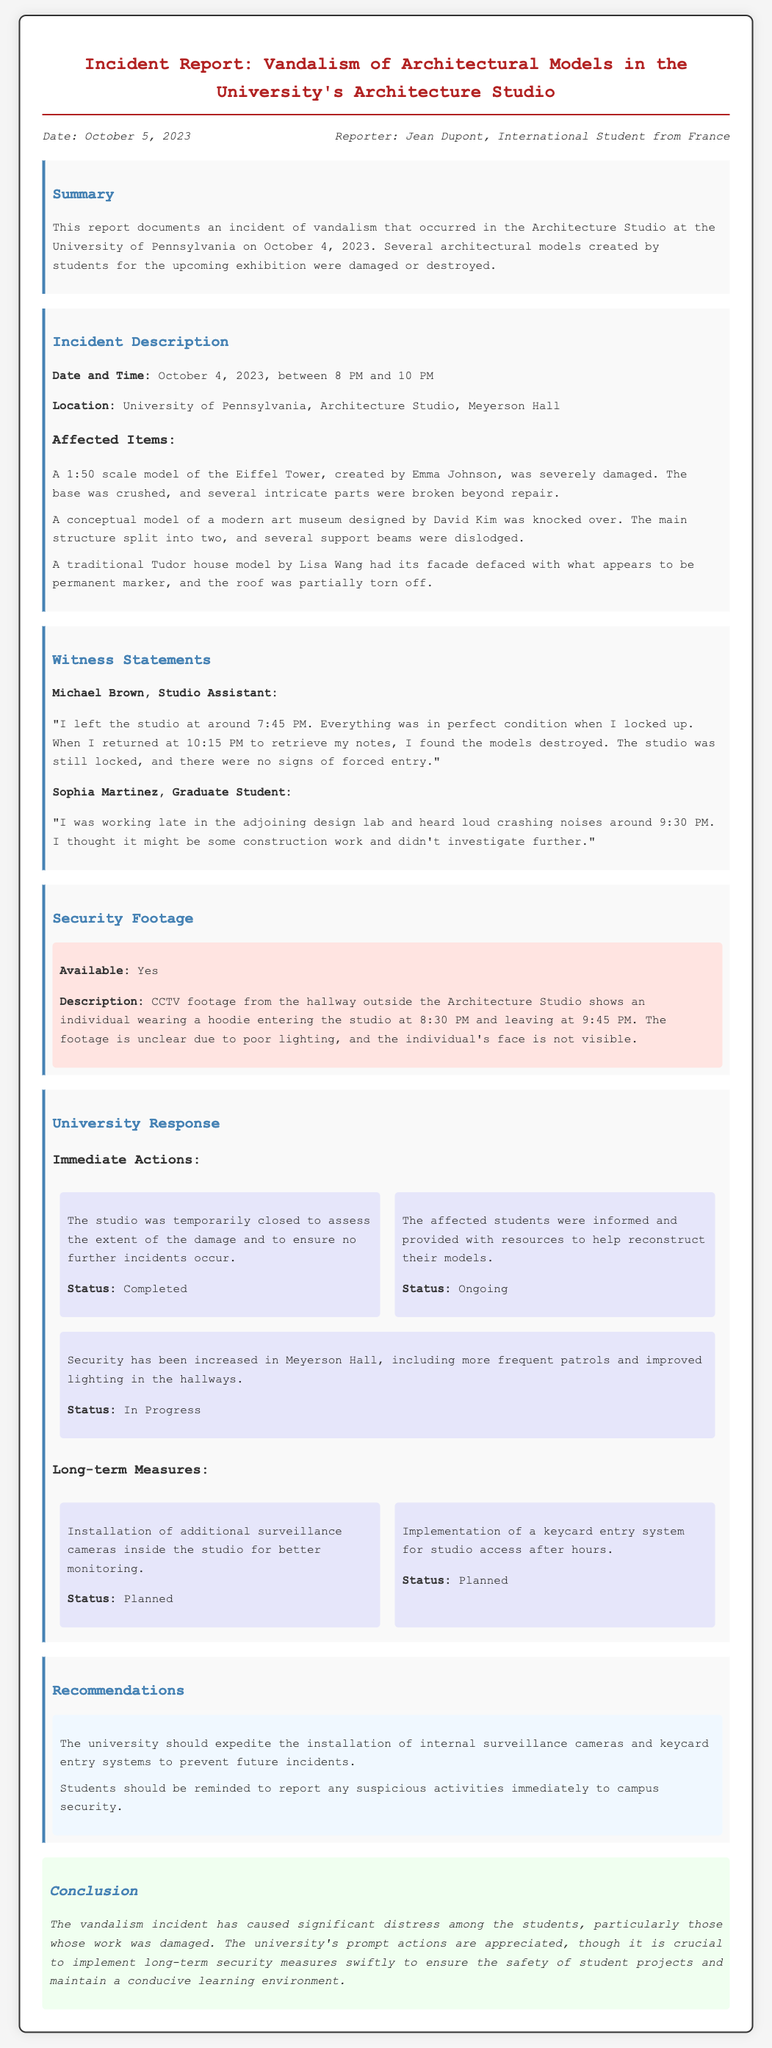What is the date of the incident? The incident occurred on October 4, 2023, as stated in the incident description.
Answer: October 4, 2023 Who is the reporter of the incident? The reporter is Jean Dupont, mentioned at the beginning of the document.
Answer: Jean Dupont How many architectural models were mentioned as affected? Three architectural models are detailed in the document as being damaged or destroyed.
Answer: Three What was the condition of the studio when Michael Brown left? Michael Brown noted that everything was in perfect condition when he left the studio.
Answer: Perfect condition What time did the vandalism occur? The vandalism took place between 8 PM and 10 PM, as outlined in the incident description.
Answer: Between 8 PM and 10 PM What long-term measure is planned for better monitoring? The installation of additional surveillance cameras inside the studio is planned.
Answer: Additional surveillance cameras What type of jacket was the individual wearing in the security footage? The individual in the security footage is described as wearing a hoodie.
Answer: Hoodie What was Emma Johnson's model? The affected model created by Emma Johnson was a scale model of the Eiffel Tower.
Answer: Scale model of the Eiffel Tower How did the vandalism affect the students? The incident has caused significant distress among the students, according to the conclusion.
Answer: Significant distress 